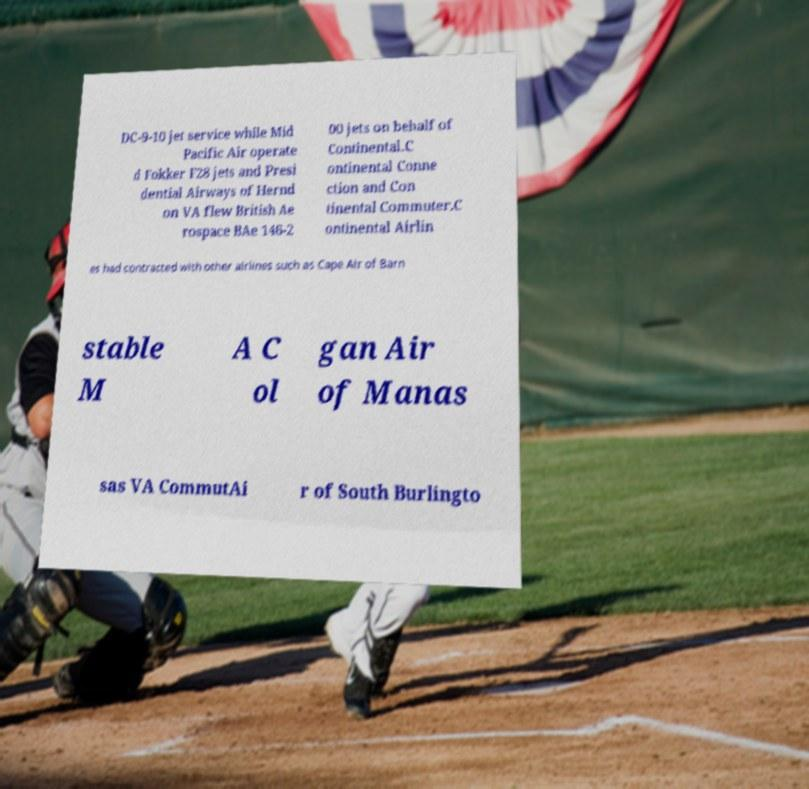For documentation purposes, I need the text within this image transcribed. Could you provide that? DC-9-10 jet service while Mid Pacific Air operate d Fokker F28 jets and Presi dential Airways of Hernd on VA flew British Ae rospace BAe 146-2 00 jets on behalf of Continental.C ontinental Conne ction and Con tinental Commuter.C ontinental Airlin es had contracted with other airlines such as Cape Air of Barn stable M A C ol gan Air of Manas sas VA CommutAi r of South Burlingto 